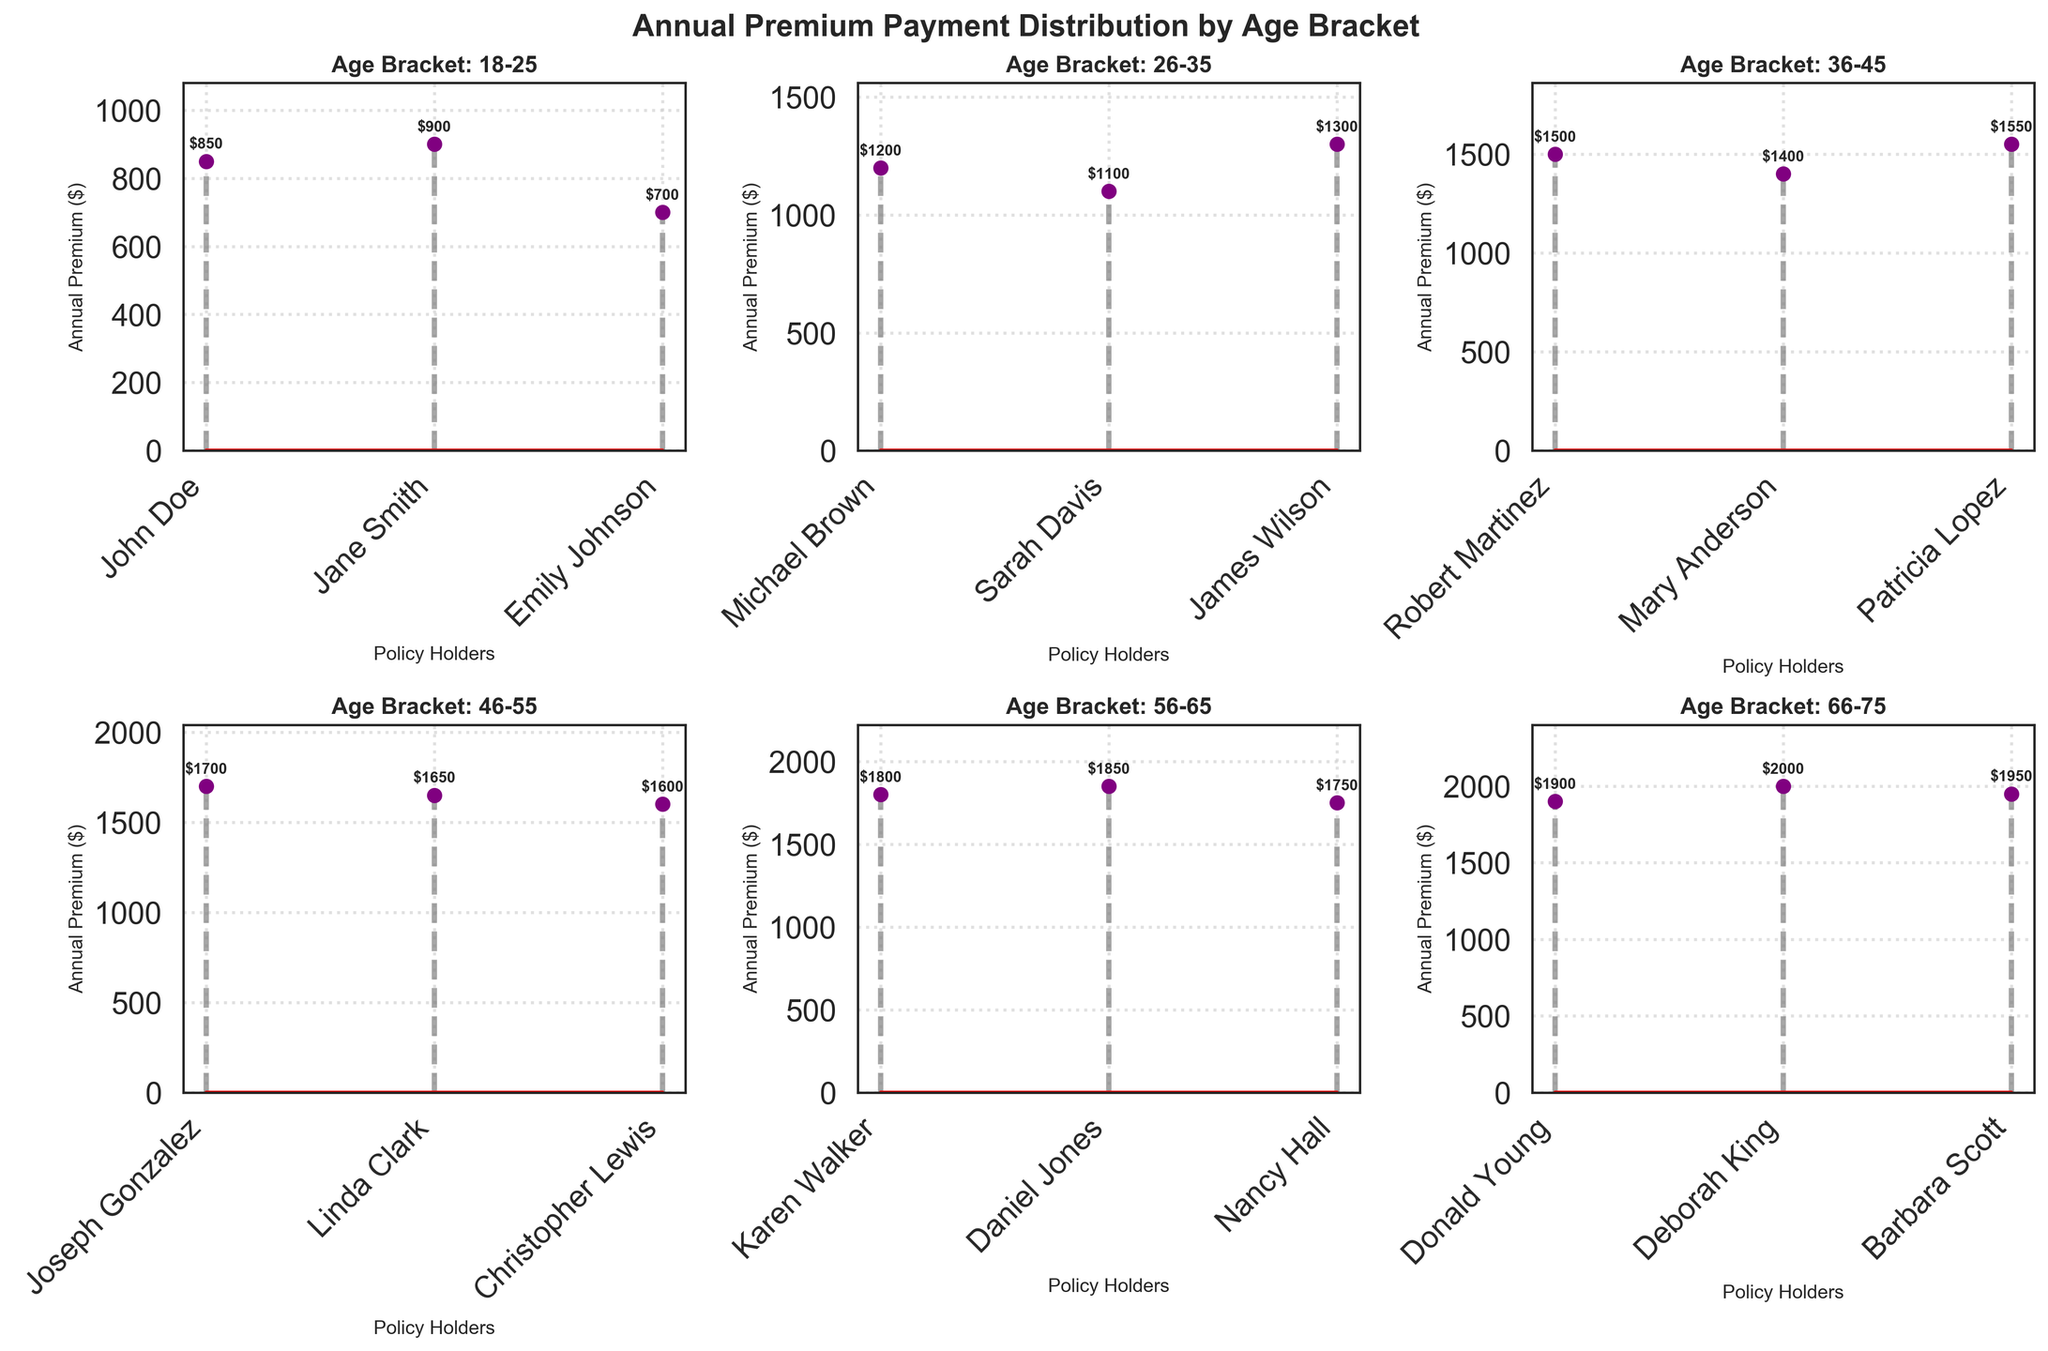what is the figure title? The title is usually displayed at the top of the figure. In this case, it states the overall topic of the plots which is "Annual Premium Payment Distribution by Age Bracket".
Answer: Annual Premium Payment Distribution by Age Bracket Which age bracket has the highest annual premium among their policy holders? By examining the highest value among all the subplots representing different age brackets as indicated by the y-axis, the highest premium appears in the 66-75 age bracket.
Answer: 66-75 What is the average annual premium for the age bracket 26-35? To find the average, add the annual premiums for this bracket and divide by the number of policies. (1200 + 1100 + 1300) / 3 = 3600 / 3 = 1200.
Answer: 1200 How many policyholders are in the age bracket 46-55? Count the number of individual markers (policyholders) in the specified age bracket subplot. There are 3 markers in the 46-55 bracket.
Answer: 3 Which policyholder has the lowest annual premium among all age brackets and what is the amount? Identify the lowest y-value among all the subplots. This value is the lowest premium. The pointer near `Emily Johnson` in '18-25' indicates the lowest value of $700.
Answer: Emily Johnson, 700 What is the sum of annual premiums for all policyholders in the age bracket 56-65? Add the annual premiums for each policyholder in this bracket. 1800 + 1850 + 1750 = 5400.
Answer: 5400 Compare the highest annual premium for the age bracket 36-45 and 46-55. Which bracket is higher and by how much? Find the highest value in each of these subplots and compute the difference. The highest in 36-45 is $1550 and in 46-55 is $1700. So, 1700 - 1550 = 150.
Answer: 46-55, 150 What are the different marker and line characteristics used in the stem plots? The markers are purple circles ('o'), stem lines are gray dashed lines ('--'), and baselines are solid red lines.
Answer: Purple circles, gray dashed lines, red solid lines How do the premiums vary among policyholders in the 66-75 age bracket? Assess the range and distribution of values. The premiums in this bracket range from $1900 to $2000, indicating a small variation and higher consistency among premiums compared to younger age brackets.
Answer: Range: $1900 to $2000 